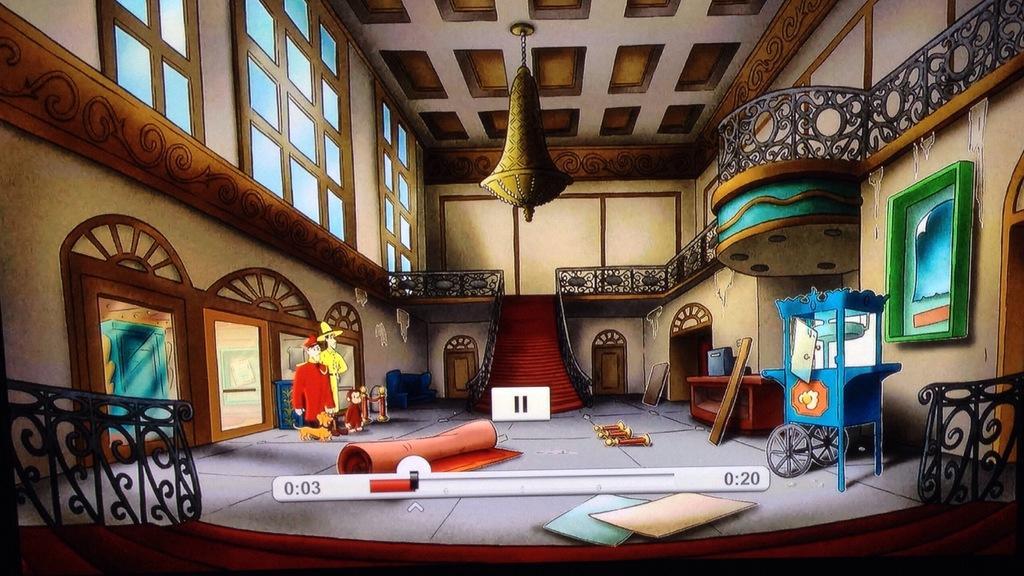Please provide a concise description of this image. In this picture we can observe a room in which there is a red color carpet. We can observe a blue color vehicle here. There are chairs and a railing. We can observe a chandelier. On the left side there are windows. We can observe a wall in the background which is in cream color. 